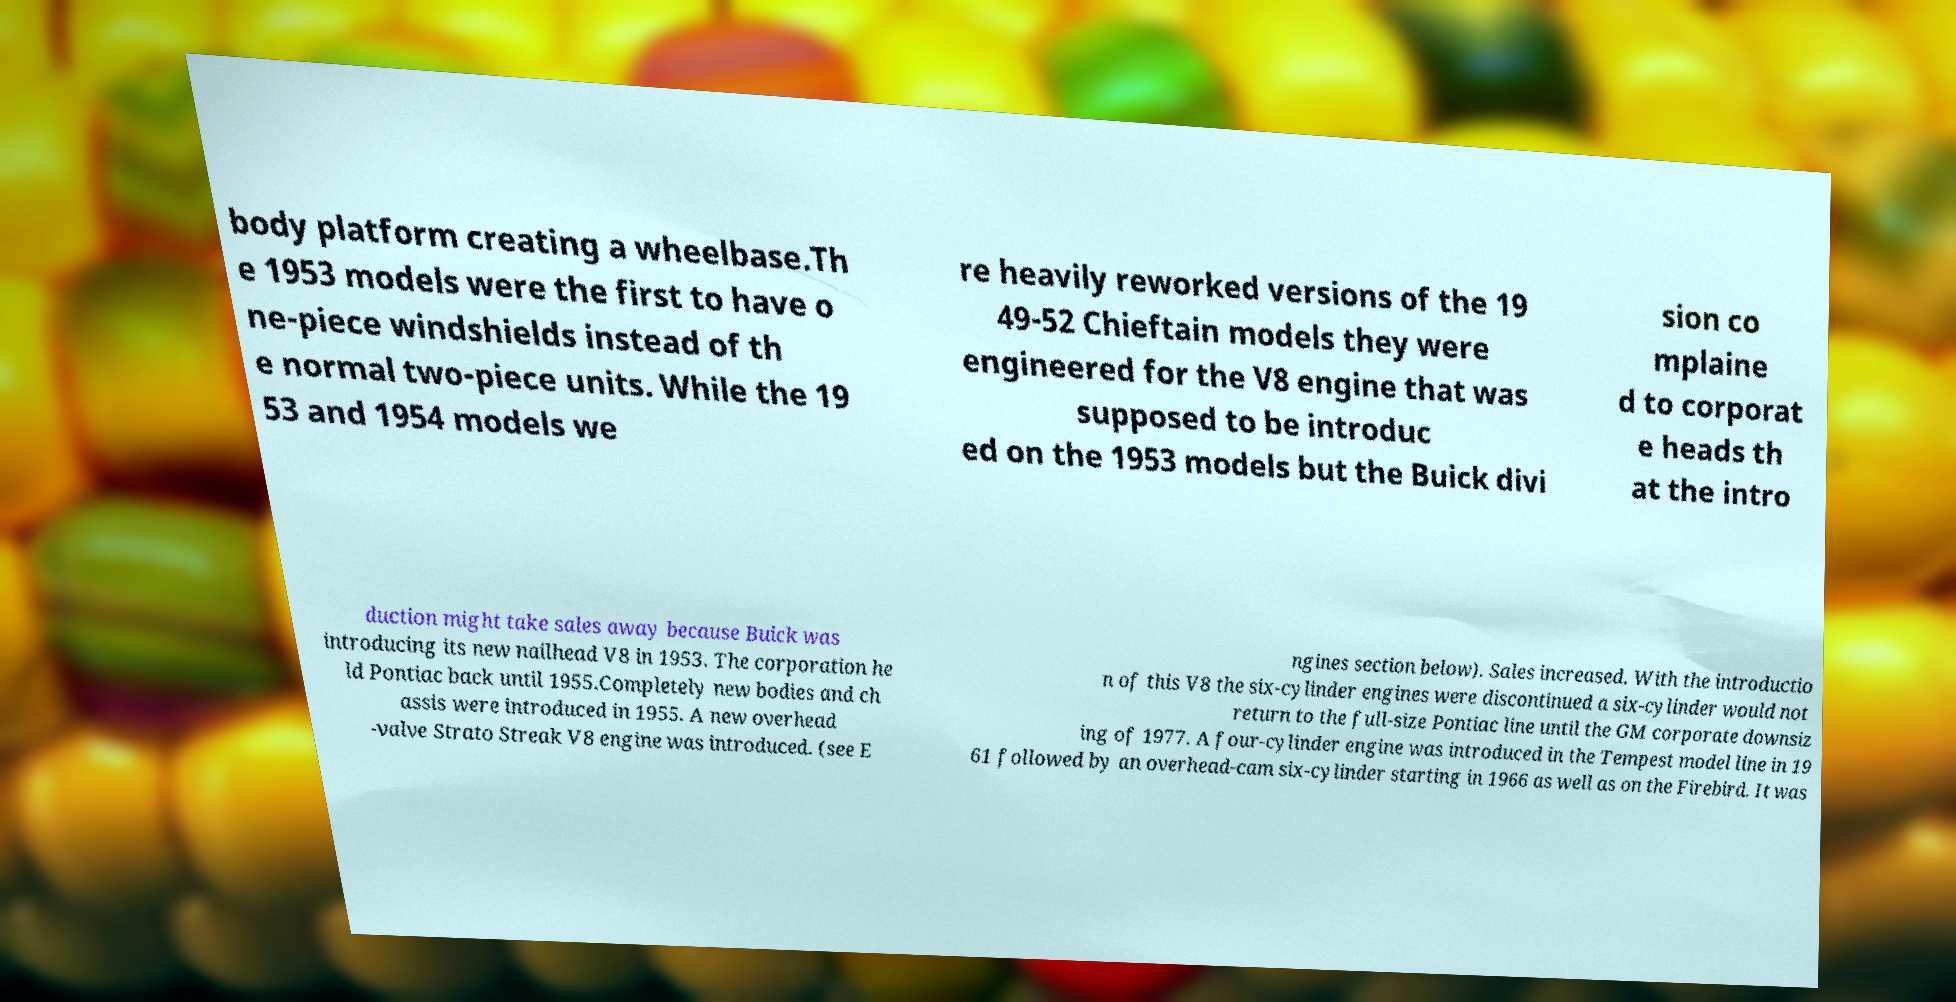Can you read and provide the text displayed in the image?This photo seems to have some interesting text. Can you extract and type it out for me? body platform creating a wheelbase.Th e 1953 models were the first to have o ne-piece windshields instead of th e normal two-piece units. While the 19 53 and 1954 models we re heavily reworked versions of the 19 49-52 Chieftain models they were engineered for the V8 engine that was supposed to be introduc ed on the 1953 models but the Buick divi sion co mplaine d to corporat e heads th at the intro duction might take sales away because Buick was introducing its new nailhead V8 in 1953. The corporation he ld Pontiac back until 1955.Completely new bodies and ch assis were introduced in 1955. A new overhead -valve Strato Streak V8 engine was introduced. (see E ngines section below). Sales increased. With the introductio n of this V8 the six-cylinder engines were discontinued a six-cylinder would not return to the full-size Pontiac line until the GM corporate downsiz ing of 1977. A four-cylinder engine was introduced in the Tempest model line in 19 61 followed by an overhead-cam six-cylinder starting in 1966 as well as on the Firebird. It was 